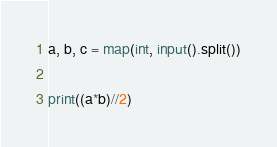Convert code to text. <code><loc_0><loc_0><loc_500><loc_500><_Python_>a, b, c = map(int, input().split())

print((a*b)//2)</code> 